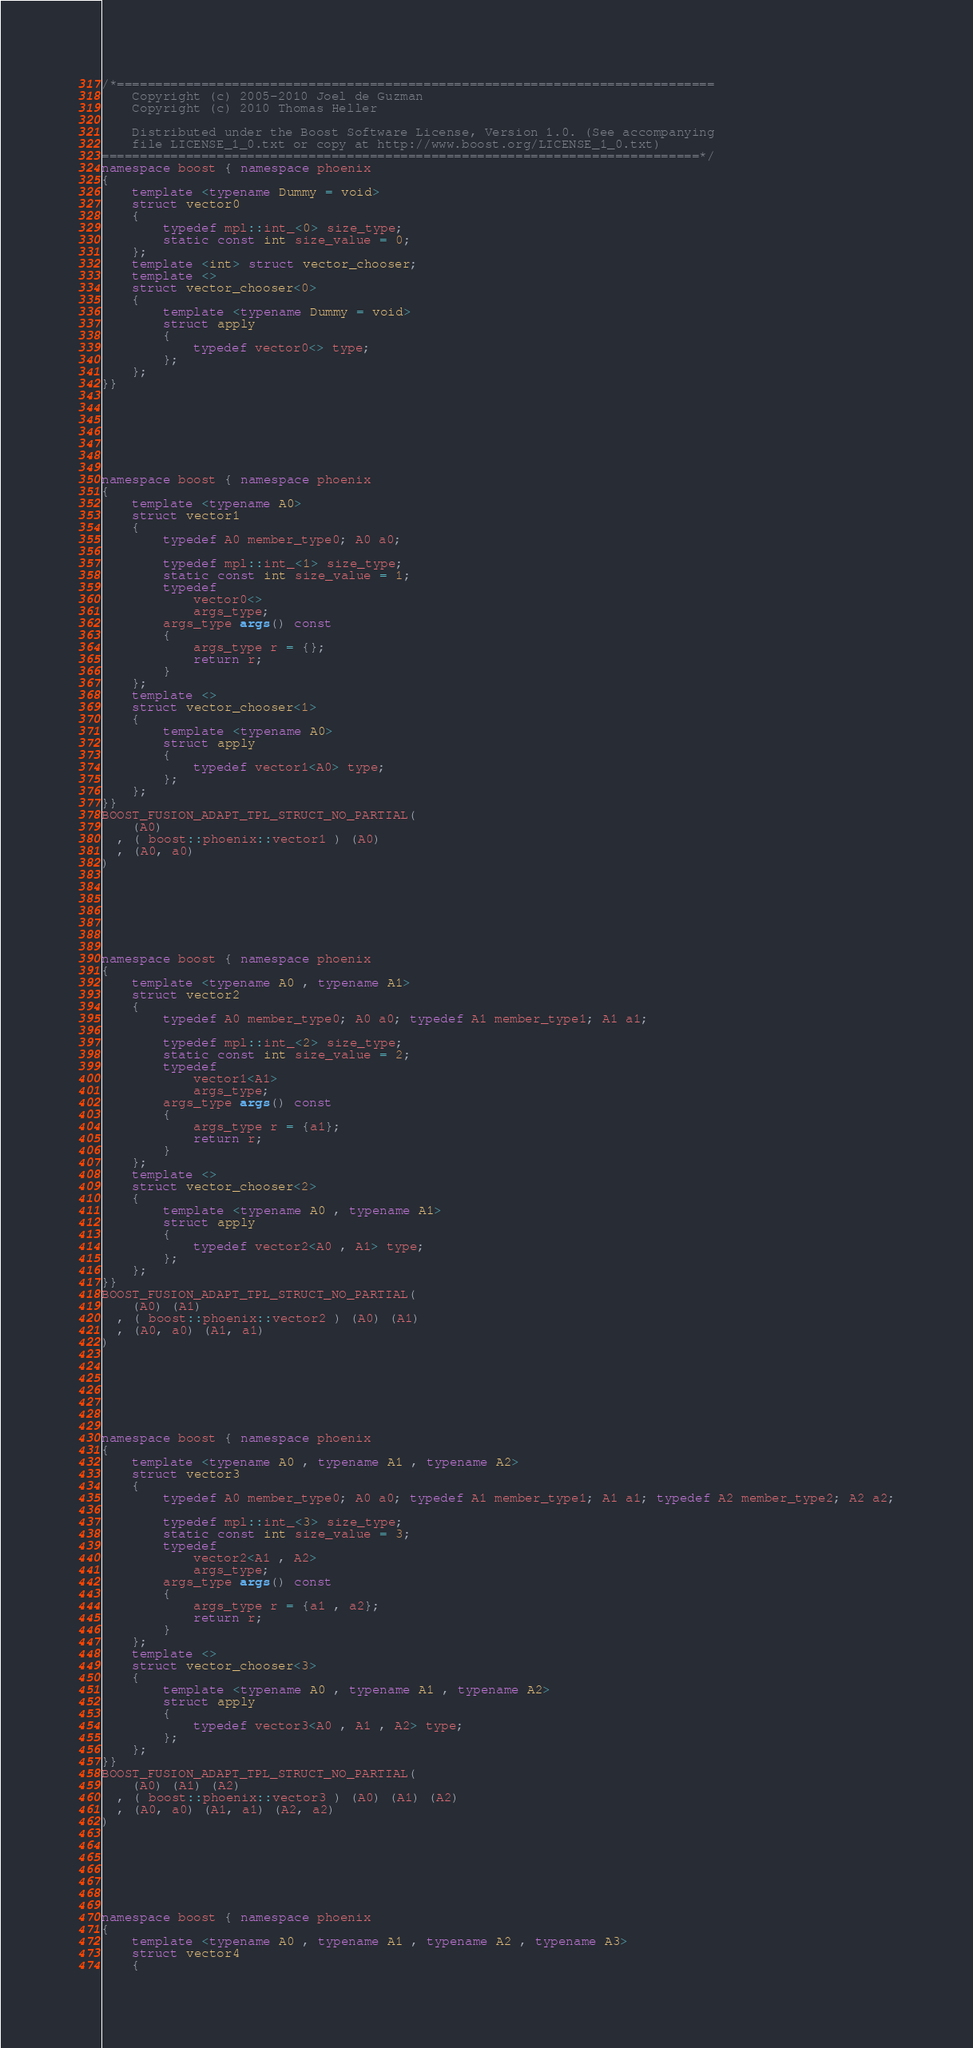Convert code to text. <code><loc_0><loc_0><loc_500><loc_500><_C++_>/*==============================================================================
    Copyright (c) 2005-2010 Joel de Guzman
    Copyright (c) 2010 Thomas Heller

    Distributed under the Boost Software License, Version 1.0. (See accompanying
    file LICENSE_1_0.txt or copy at http://www.boost.org/LICENSE_1_0.txt)
==============================================================================*/
namespace boost { namespace phoenix
{
    template <typename Dummy = void>
    struct vector0
    {
        typedef mpl::int_<0> size_type;
        static const int size_value = 0;
    };
    template <int> struct vector_chooser;
    template <>
    struct vector_chooser<0>
    {
        template <typename Dummy = void>
        struct apply
        {
            typedef vector0<> type;
        };
    };
}}







namespace boost { namespace phoenix
{
    template <typename A0>
    struct vector1
    {
        typedef A0 member_type0; A0 a0;

        typedef mpl::int_<1> size_type;
        static const int size_value = 1;
        typedef
            vector0<>
            args_type;
        args_type args() const
        {
            args_type r = {};
            return r;
        }
    };
    template <>
    struct vector_chooser<1>
    {
        template <typename A0>
        struct apply
        {
            typedef vector1<A0> type;
        };
    };
}}
BOOST_FUSION_ADAPT_TPL_STRUCT_NO_PARTIAL(
    (A0)
  , ( boost::phoenix::vector1 ) (A0)
  , (A0, a0)
)







namespace boost { namespace phoenix
{
    template <typename A0 , typename A1>
    struct vector2
    {
        typedef A0 member_type0; A0 a0; typedef A1 member_type1; A1 a1;

        typedef mpl::int_<2> size_type;
        static const int size_value = 2;
        typedef
            vector1<A1>
            args_type;
        args_type args() const
        {
            args_type r = {a1};
            return r;
        }
    };
    template <>
    struct vector_chooser<2>
    {
        template <typename A0 , typename A1>
        struct apply
        {
            typedef vector2<A0 , A1> type;
        };
    };
}}
BOOST_FUSION_ADAPT_TPL_STRUCT_NO_PARTIAL(
    (A0) (A1)
  , ( boost::phoenix::vector2 ) (A0) (A1)
  , (A0, a0) (A1, a1)
)







namespace boost { namespace phoenix
{
    template <typename A0 , typename A1 , typename A2>
    struct vector3
    {
        typedef A0 member_type0; A0 a0; typedef A1 member_type1; A1 a1; typedef A2 member_type2; A2 a2;

        typedef mpl::int_<3> size_type;
        static const int size_value = 3;
        typedef
            vector2<A1 , A2>
            args_type;
        args_type args() const
        {
            args_type r = {a1 , a2};
            return r;
        }
    };
    template <>
    struct vector_chooser<3>
    {
        template <typename A0 , typename A1 , typename A2>
        struct apply
        {
            typedef vector3<A0 , A1 , A2> type;
        };
    };
}}
BOOST_FUSION_ADAPT_TPL_STRUCT_NO_PARTIAL(
    (A0) (A1) (A2)
  , ( boost::phoenix::vector3 ) (A0) (A1) (A2)
  , (A0, a0) (A1, a1) (A2, a2)
)







namespace boost { namespace phoenix
{
    template <typename A0 , typename A1 , typename A2 , typename A3>
    struct vector4
    {</code> 